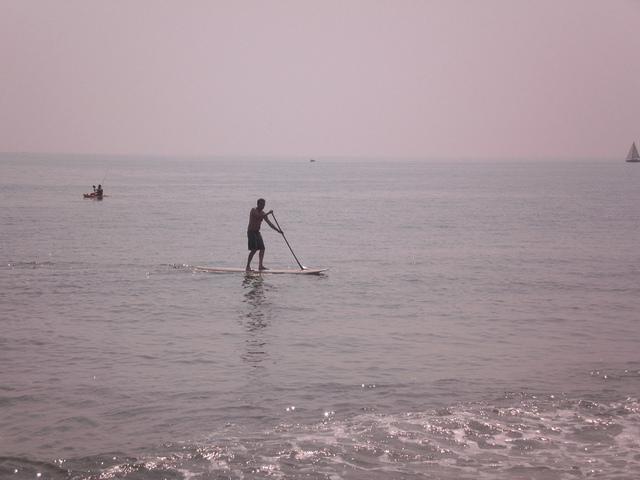How many skiers are in the picture?
Give a very brief answer. 0. How many surfboards are there?
Give a very brief answer. 1. How many oars are being used?
Give a very brief answer. 1. 